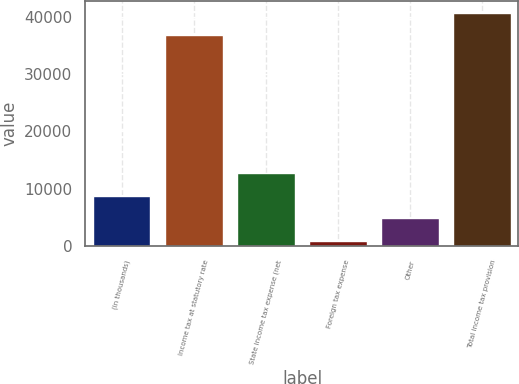<chart> <loc_0><loc_0><loc_500><loc_500><bar_chart><fcel>(in thousands)<fcel>Income tax at statutory rate<fcel>State income tax expense (net<fcel>Foreign tax expense<fcel>Other<fcel>Total income tax provision<nl><fcel>8788.4<fcel>36720<fcel>12712.6<fcel>940<fcel>4864.2<fcel>40644.2<nl></chart> 